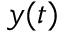<formula> <loc_0><loc_0><loc_500><loc_500>y ( t )</formula> 